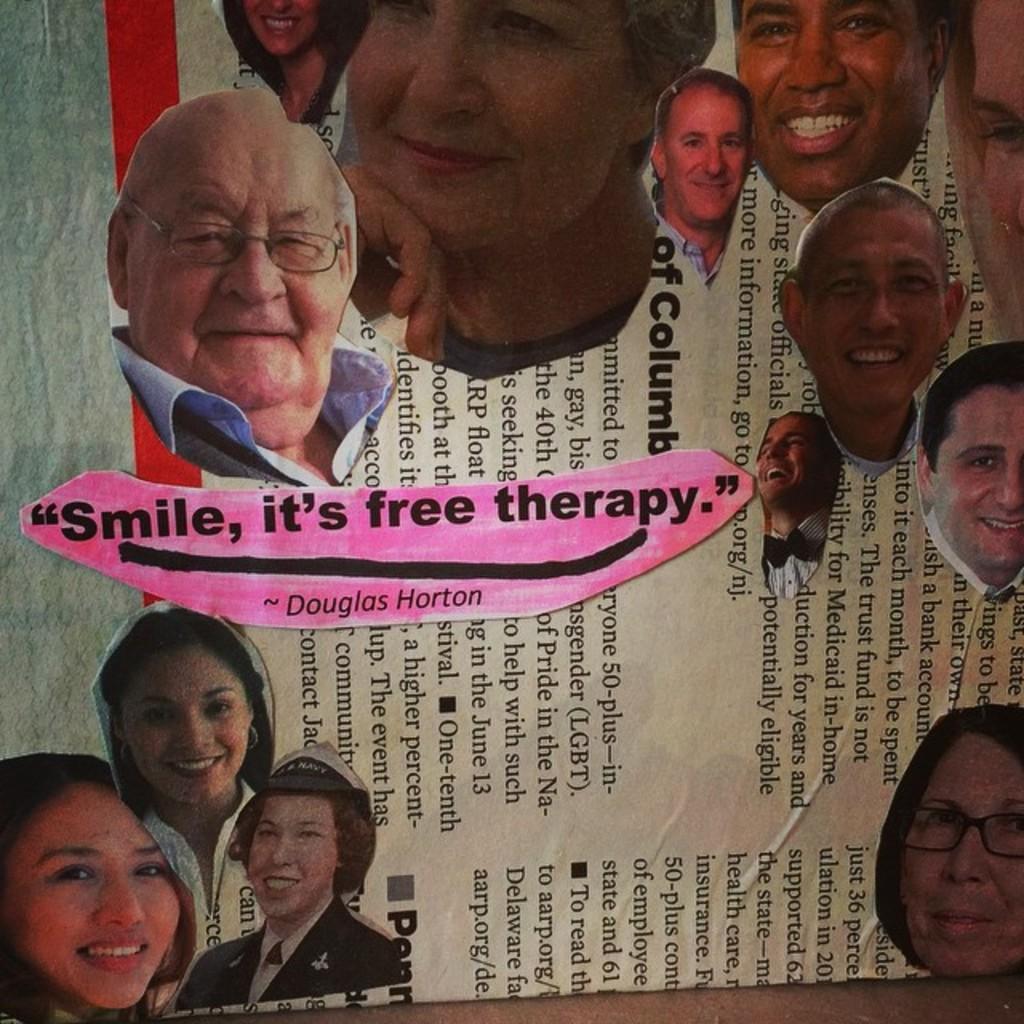Could you give a brief overview of what you see in this image? In this image there are photos of people on the paper. 